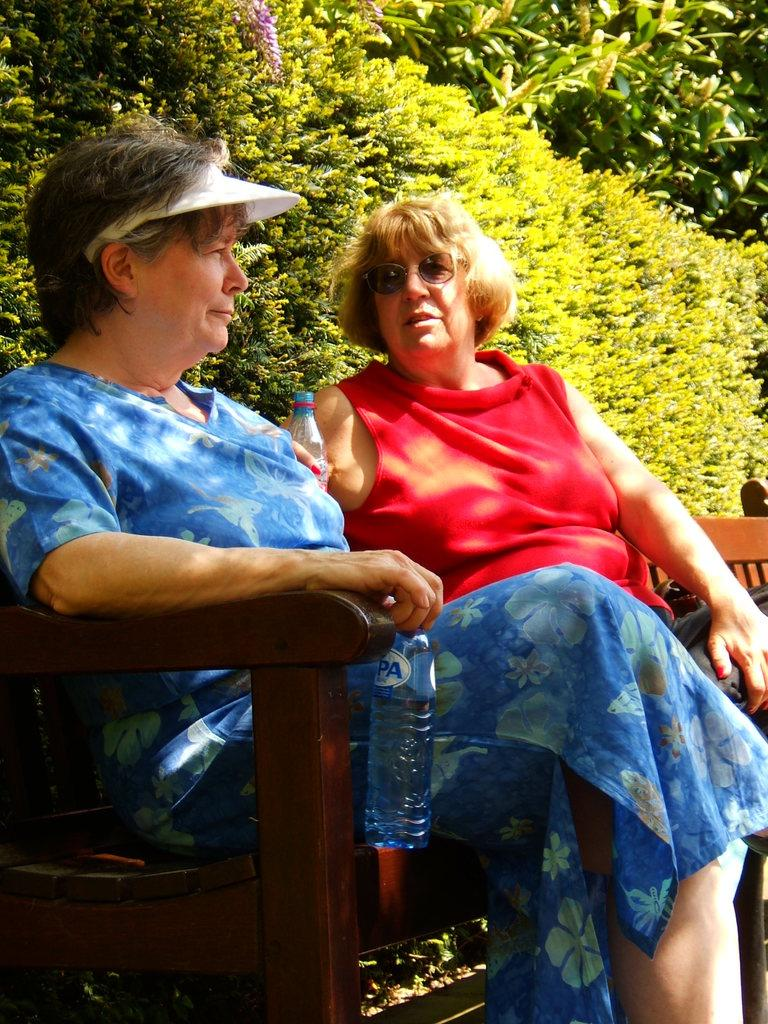How many people are in the image? There are two women in the image. What are the women doing in the image? The women are sitting on a bench. What are the women holding in their hands? The women are holding bottles in their hands. What can be seen in the background of the image? There are trees in the background of the image. What type of cars can be seen in the background of the image? There are no cars visible in the image; it only shows two women sitting on a bench and trees in the background. 